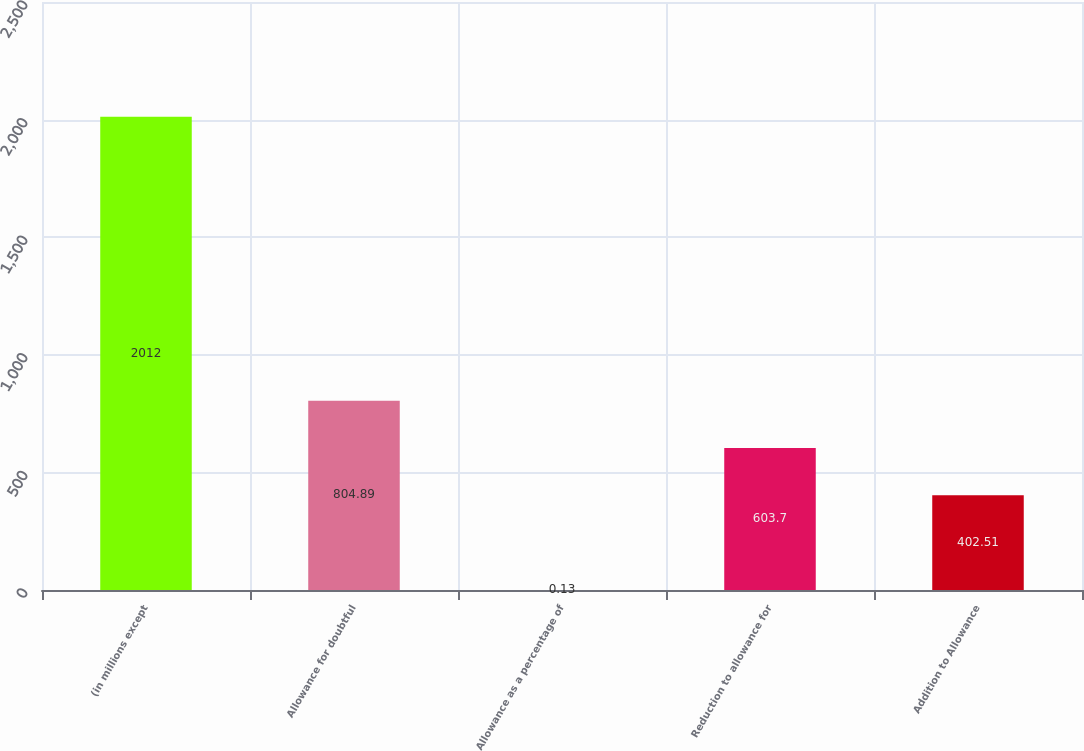Convert chart. <chart><loc_0><loc_0><loc_500><loc_500><bar_chart><fcel>(in millions except<fcel>Allowance for doubtful<fcel>Allowance as a percentage of<fcel>Reduction to allowance for<fcel>Addition to Allowance<nl><fcel>2012<fcel>804.89<fcel>0.13<fcel>603.7<fcel>402.51<nl></chart> 